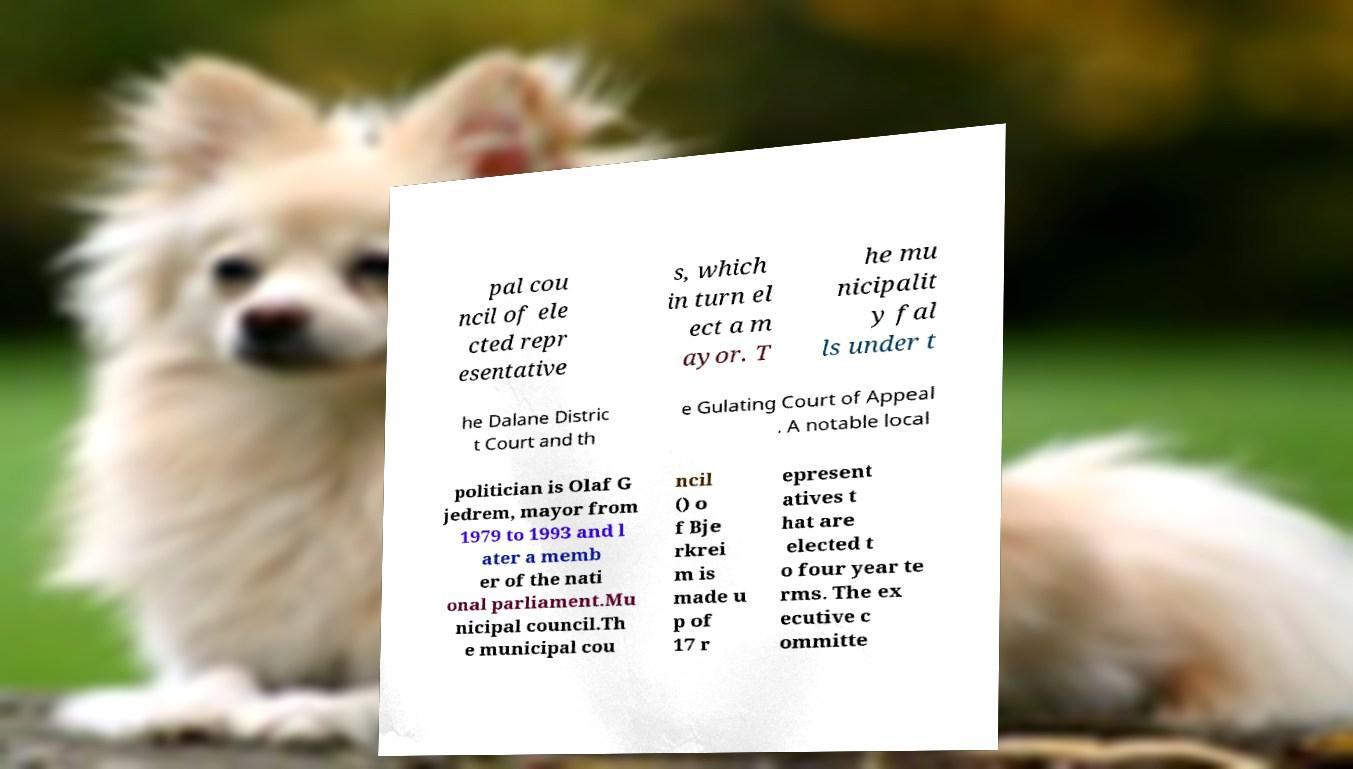Could you assist in decoding the text presented in this image and type it out clearly? pal cou ncil of ele cted repr esentative s, which in turn el ect a m ayor. T he mu nicipalit y fal ls under t he Dalane Distric t Court and th e Gulating Court of Appeal . A notable local politician is Olaf G jedrem, mayor from 1979 to 1993 and l ater a memb er of the nati onal parliament.Mu nicipal council.Th e municipal cou ncil () o f Bje rkrei m is made u p of 17 r epresent atives t hat are elected t o four year te rms. The ex ecutive c ommitte 